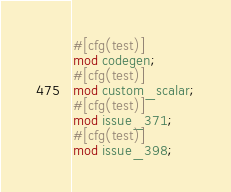Convert code to text. <code><loc_0><loc_0><loc_500><loc_500><_Rust_>#[cfg(test)]
mod codegen;
#[cfg(test)]
mod custom_scalar;
#[cfg(test)]
mod issue_371;
#[cfg(test)]
mod issue_398;
</code> 